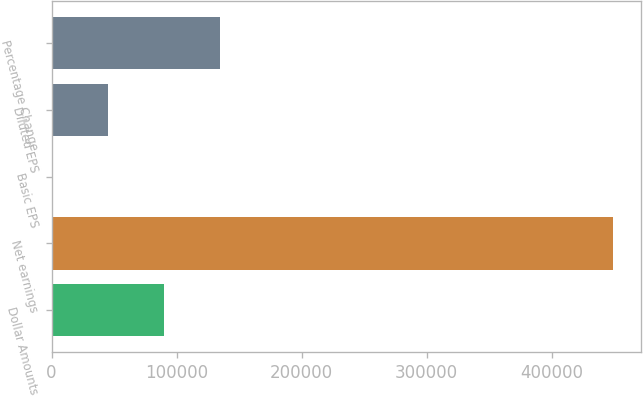Convert chart. <chart><loc_0><loc_0><loc_500><loc_500><bar_chart><fcel>Dollar Amounts<fcel>Net earnings<fcel>Basic EPS<fcel>Diluted EPS<fcel>Percentage Change<nl><fcel>89728.4<fcel>448636<fcel>1.51<fcel>44865<fcel>134592<nl></chart> 